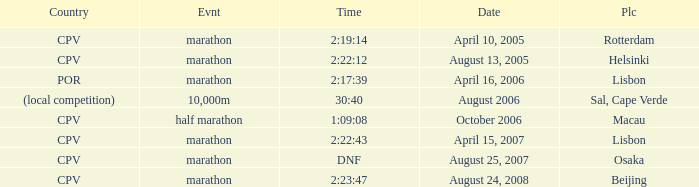What is the Place of the Event on August 25, 2007? Osaka. 